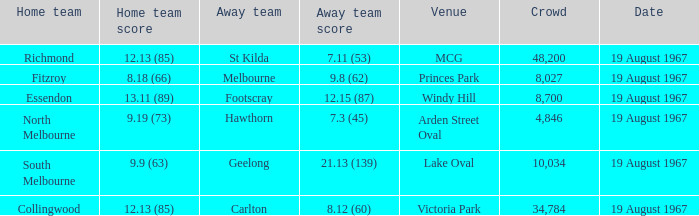3 (45), what was the score of the home team? 9.19 (73). 